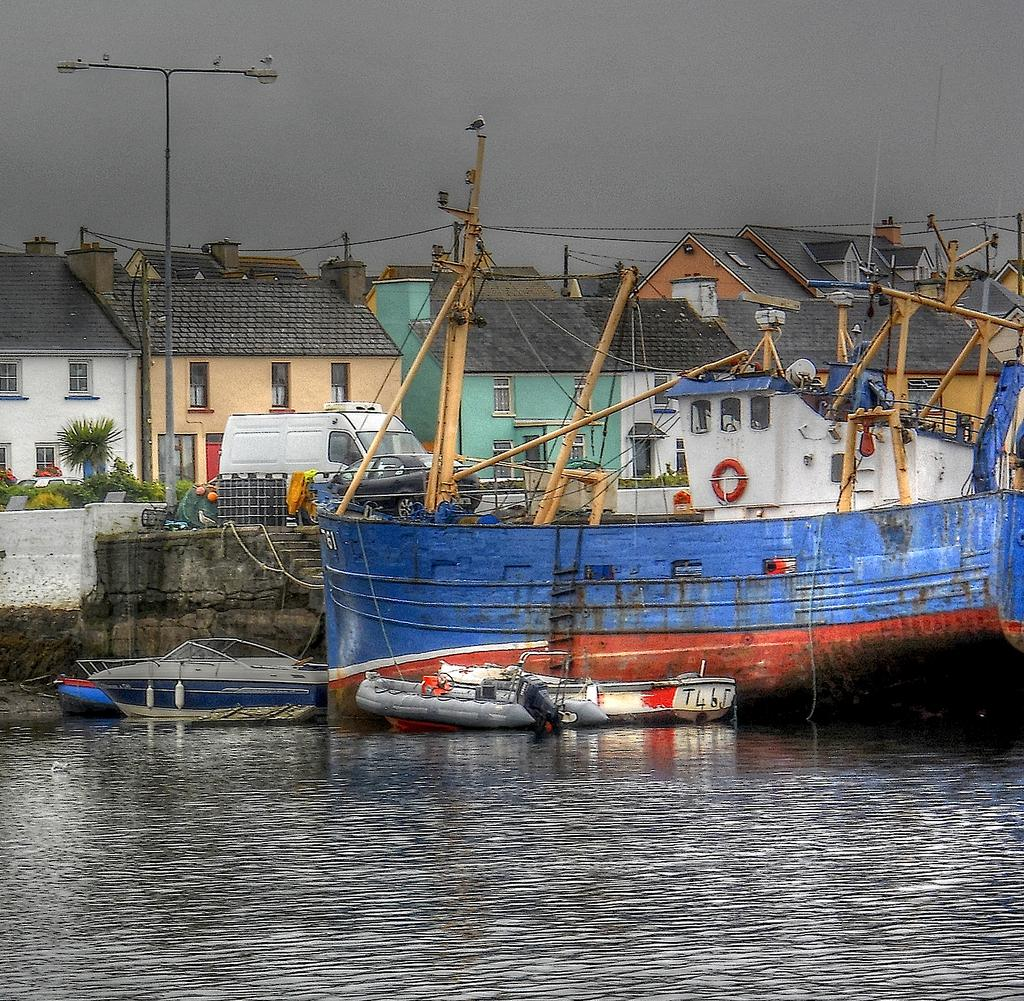What is the main element in the image? There is water in the image. What types of watercraft can be seen in the water? There are ships and small boats in the water. What can be seen in the background of the image? There are houses in the background of the image. How are the houses arranged in the background? The houses are situated one beside the other. What else is visible on the road in the image? There is a van and an electric pole on the road in the image. What type of reaction is taking place between the cent and the stocking in the image? There is no cent or stocking present in the image, so no such reaction can be observed. 